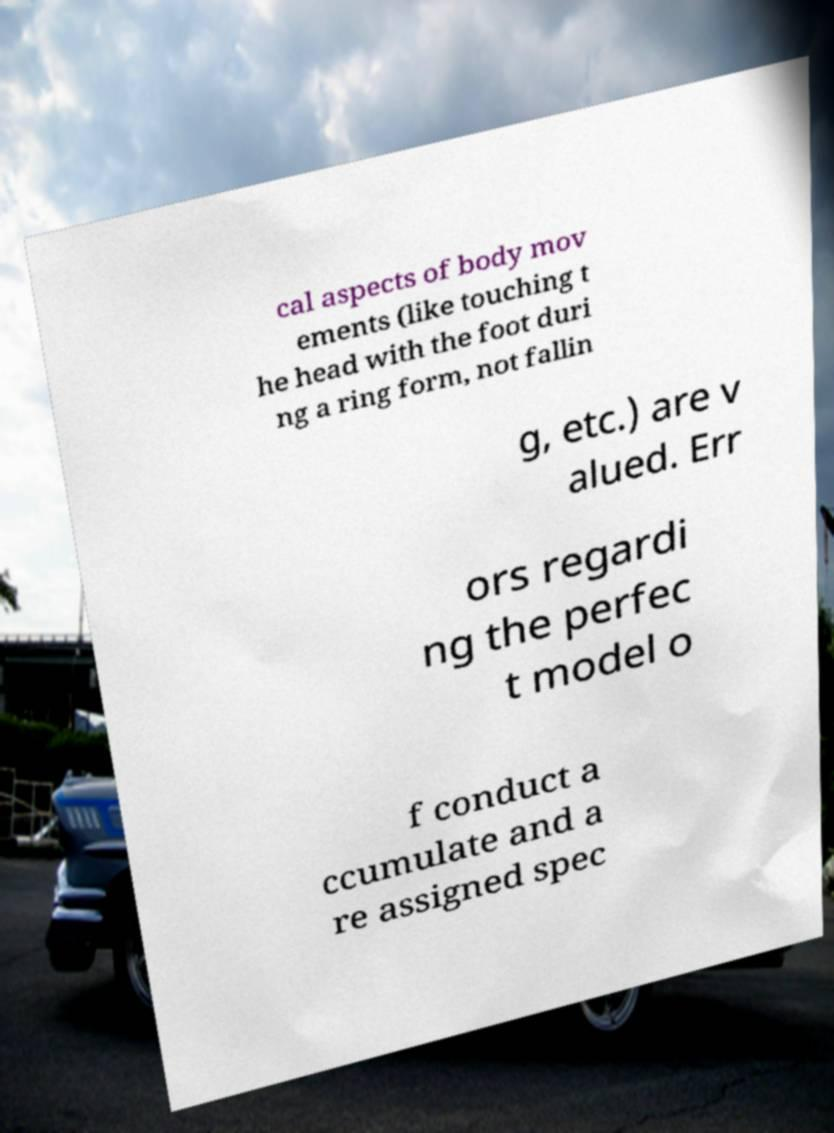There's text embedded in this image that I need extracted. Can you transcribe it verbatim? cal aspects of body mov ements (like touching t he head with the foot duri ng a ring form, not fallin g, etc.) are v alued. Err ors regardi ng the perfec t model o f conduct a ccumulate and a re assigned spec 